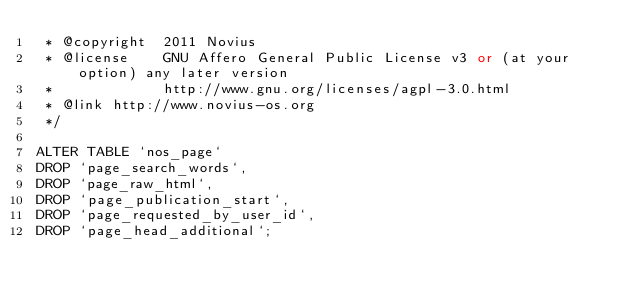<code> <loc_0><loc_0><loc_500><loc_500><_SQL_> * @copyright  2011 Novius
 * @license    GNU Affero General Public License v3 or (at your option) any later version
 *             http://www.gnu.org/licenses/agpl-3.0.html
 * @link http://www.novius-os.org
 */

ALTER TABLE `nos_page`
DROP `page_search_words`,
DROP `page_raw_html`,
DROP `page_publication_start`,
DROP `page_requested_by_user_id`,
DROP `page_head_additional`;</code> 